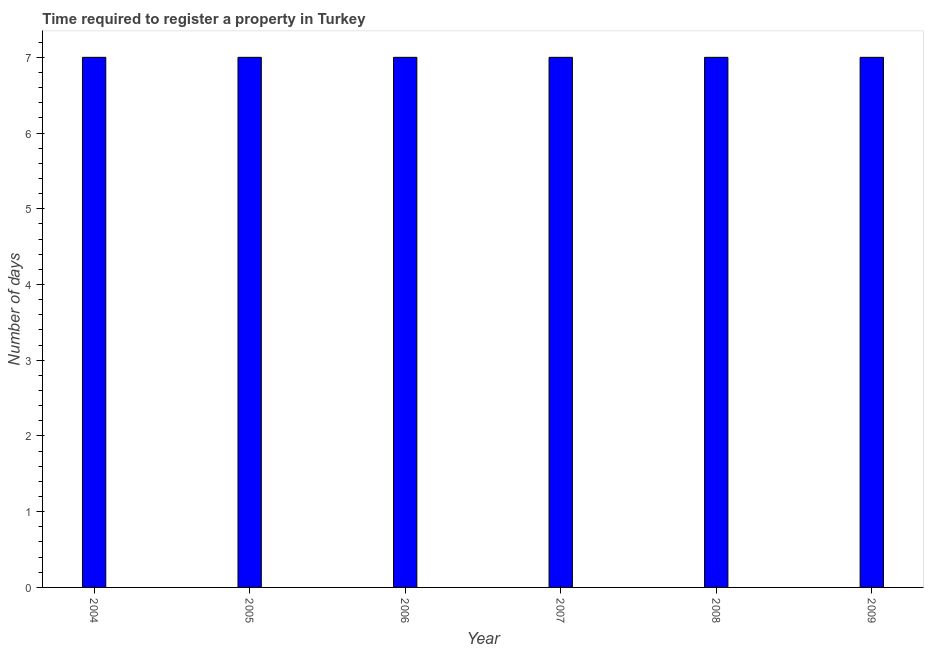Does the graph contain grids?
Offer a very short reply. No. What is the title of the graph?
Offer a very short reply. Time required to register a property in Turkey. What is the label or title of the Y-axis?
Your response must be concise. Number of days. Across all years, what is the maximum number of days required to register property?
Make the answer very short. 7. Across all years, what is the minimum number of days required to register property?
Offer a very short reply. 7. What is the sum of the number of days required to register property?
Ensure brevity in your answer.  42. What is the average number of days required to register property per year?
Your answer should be compact. 7. In how many years, is the number of days required to register property greater than 5.2 days?
Your answer should be very brief. 6. What is the ratio of the number of days required to register property in 2004 to that in 2005?
Ensure brevity in your answer.  1. Is the difference between the number of days required to register property in 2005 and 2007 greater than the difference between any two years?
Provide a short and direct response. Yes. What is the difference between the highest and the second highest number of days required to register property?
Provide a succinct answer. 0. Is the sum of the number of days required to register property in 2005 and 2007 greater than the maximum number of days required to register property across all years?
Your answer should be compact. Yes. In how many years, is the number of days required to register property greater than the average number of days required to register property taken over all years?
Your answer should be very brief. 0. How many bars are there?
Offer a very short reply. 6. Are all the bars in the graph horizontal?
Your response must be concise. No. Are the values on the major ticks of Y-axis written in scientific E-notation?
Keep it short and to the point. No. What is the Number of days in 2006?
Provide a short and direct response. 7. What is the Number of days of 2008?
Provide a succinct answer. 7. What is the Number of days in 2009?
Provide a succinct answer. 7. What is the difference between the Number of days in 2004 and 2008?
Offer a terse response. 0. What is the difference between the Number of days in 2004 and 2009?
Keep it short and to the point. 0. What is the difference between the Number of days in 2005 and 2008?
Provide a succinct answer. 0. What is the difference between the Number of days in 2005 and 2009?
Make the answer very short. 0. What is the difference between the Number of days in 2006 and 2007?
Provide a succinct answer. 0. What is the difference between the Number of days in 2006 and 2008?
Make the answer very short. 0. What is the ratio of the Number of days in 2004 to that in 2006?
Offer a very short reply. 1. What is the ratio of the Number of days in 2004 to that in 2007?
Your response must be concise. 1. What is the ratio of the Number of days in 2005 to that in 2008?
Provide a short and direct response. 1. What is the ratio of the Number of days in 2007 to that in 2008?
Your response must be concise. 1. What is the ratio of the Number of days in 2007 to that in 2009?
Offer a terse response. 1. 